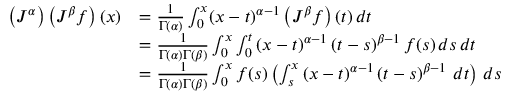<formula> <loc_0><loc_0><loc_500><loc_500>{ \begin{array} { r l } { \left ( J ^ { \alpha } \right ) \left ( J ^ { \beta } f \right ) ( x ) } & { = { \frac { 1 } { \Gamma ( \alpha ) } } \int _ { 0 } ^ { x } ( x - t ) ^ { \alpha - 1 } \left ( J ^ { \beta } f \right ) ( t ) \, d t } \\ & { = { \frac { 1 } { \Gamma ( \alpha ) \Gamma ( \beta ) } } \int _ { 0 } ^ { x } \int _ { 0 } ^ { t } \left ( x - t \right ) ^ { \alpha - 1 } \left ( t - s \right ) ^ { \beta - 1 } f ( s ) \, d s \, d t } \\ & { = { \frac { 1 } { \Gamma ( \alpha ) \Gamma ( \beta ) } } \int _ { 0 } ^ { x } f ( s ) \left ( \int _ { s } ^ { x } \left ( x - t \right ) ^ { \alpha - 1 } \left ( t - s \right ) ^ { \beta - 1 } \, d t \right ) \, d s } \end{array} }</formula> 